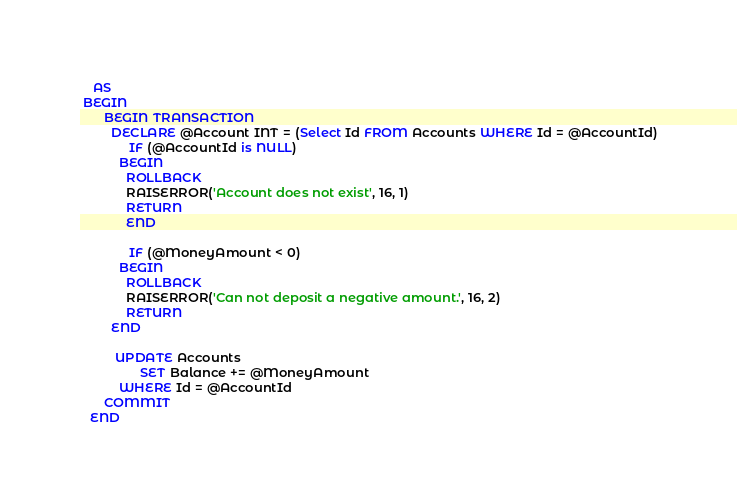<code> <loc_0><loc_0><loc_500><loc_500><_SQL_>    AS
 BEGIN
       BEGIN TRANSACTION
	     DECLARE @Account INT = (Select Id FROM Accounts WHERE Id = @AccountId)
	          IF (@AccountId is NULL)
	       BEGIN
		     ROLLBACK
		     RAISERROR('Account does not exist', 16, 1)
		     RETURN
	         END

	          IF (@MoneyAmount < 0)
	       BEGIN
		     ROLLBACK
		     RAISERROR('Can not deposit a negative amount.', 16, 2)
		     RETURN
		 END

	      UPDATE Accounts
                 SET Balance += @MoneyAmount
	       WHERE Id = @AccountId
       COMMIT
   END</code> 